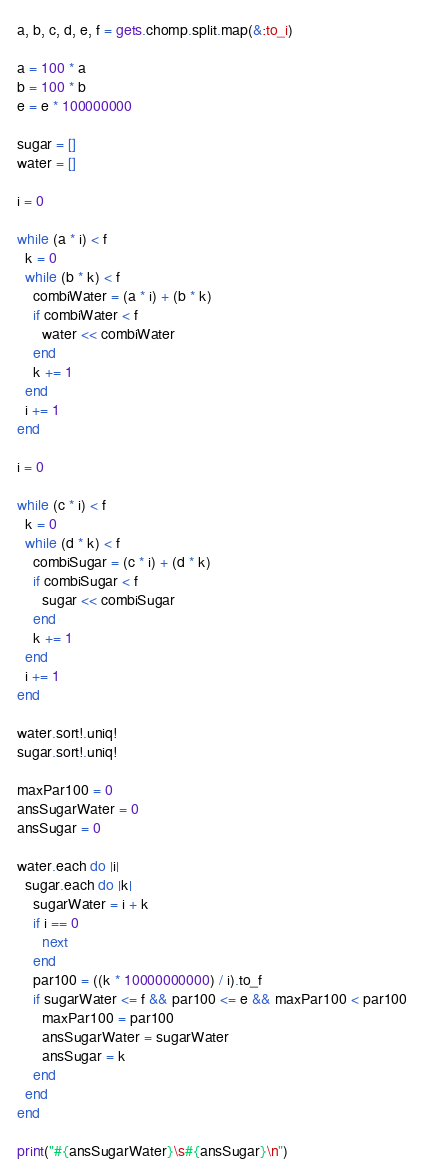Convert code to text. <code><loc_0><loc_0><loc_500><loc_500><_Ruby_>a, b, c, d, e, f = gets.chomp.split.map(&:to_i)

a = 100 * a 
b = 100 * b
e = e * 100000000

sugar = []
water = []

i = 0

while (a * i) < f
  k = 0
  while (b * k) < f
    combiWater = (a * i) + (b * k)
    if combiWater < f
      water << combiWater
    end
    k += 1
  end
  i += 1
end

i = 0

while (c * i) < f
  k = 0
  while (d * k) < f
    combiSugar = (c * i) + (d * k)
    if combiSugar < f
      sugar << combiSugar
    end
    k += 1
  end
  i += 1
end

water.sort!.uniq!
sugar.sort!.uniq!

maxPar100 = 0
ansSugarWater = 0
ansSugar = 0

water.each do |i|
  sugar.each do |k|
    sugarWater = i + k
    if i == 0
      next
    end
    par100 = ((k * 10000000000) / i).to_f
    if sugarWater <= f && par100 <= e && maxPar100 < par100
      maxPar100 = par100
      ansSugarWater = sugarWater
      ansSugar = k
    end
  end
end

print("#{ansSugarWater}\s#{ansSugar}\n")

</code> 